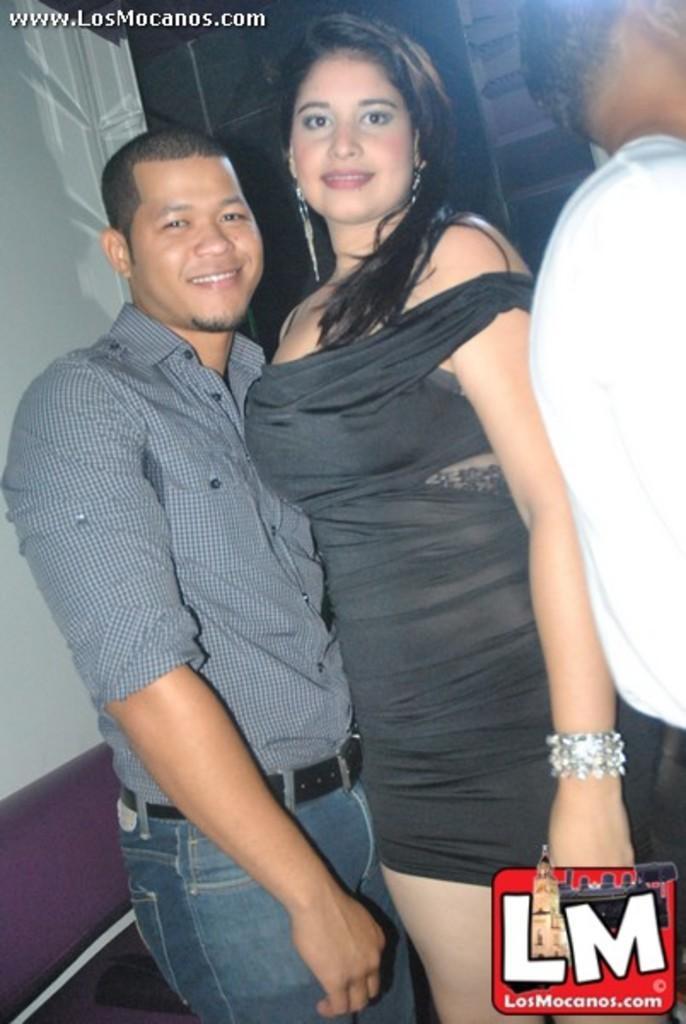How would you summarize this image in a sentence or two? In this image there are two persons standing and smiling, there is another person , and in the background there are some items , and there are watermarks on the image. 